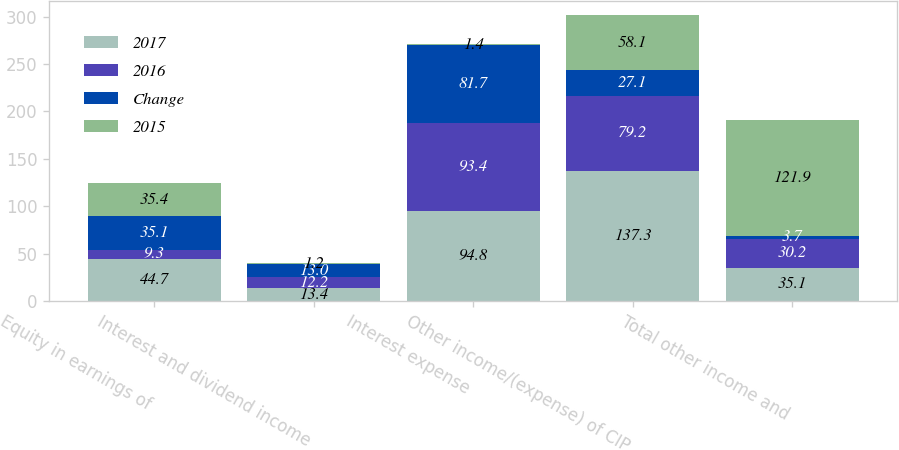<chart> <loc_0><loc_0><loc_500><loc_500><stacked_bar_chart><ecel><fcel>Equity in earnings of<fcel>Interest and dividend income<fcel>Interest expense<fcel>Other income/(expense) of CIP<fcel>Total other income and<nl><fcel>2017<fcel>44.7<fcel>13.4<fcel>94.8<fcel>137.3<fcel>35.1<nl><fcel>2016<fcel>9.3<fcel>12.2<fcel>93.4<fcel>79.2<fcel>30.2<nl><fcel>Change<fcel>35.1<fcel>13<fcel>81.7<fcel>27.1<fcel>3.7<nl><fcel>2015<fcel>35.4<fcel>1.2<fcel>1.4<fcel>58.1<fcel>121.9<nl></chart> 